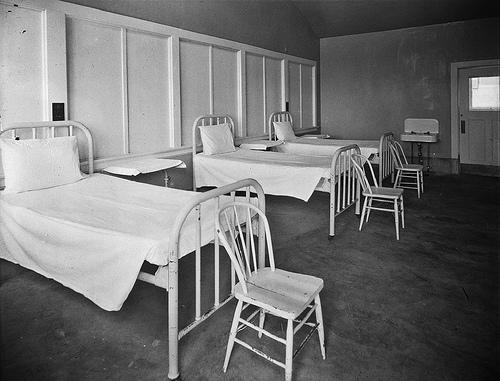This room looks like an old type of what? hospital 